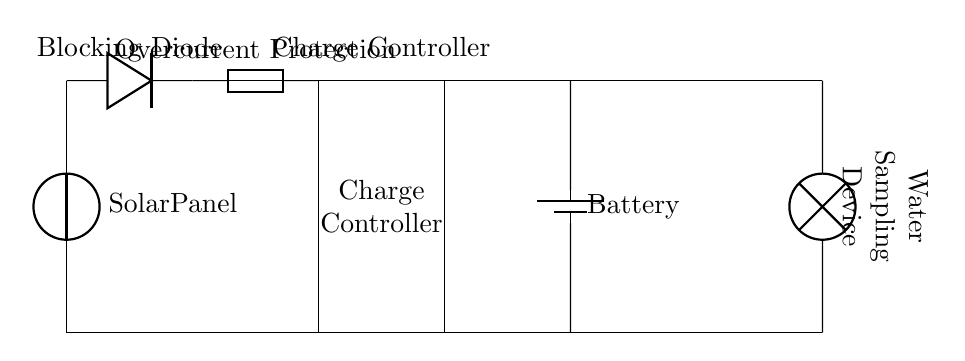What is the function of the blocking diode? The blocking diode prevents reverse current from flowing back into the solar panel when it is not generating power. It ensures that energy stored in the battery does not flow back to the solar panel at night or during low light conditions.
Answer: Preventing reverse current What component provides overcurrent protection? The component labeled "Overcurrent Protection" is a fuse. Its purpose is to break the circuit if the current exceeds a certain threshold, protecting other components from damage due to excessive current.
Answer: Fuse How many main components are there in the circuit? The circuit includes four main components: the solar panel, the diode, the charge controller, and the battery. This straightforward counting can be seen directly from the diagram.
Answer: Four What device is the load in this circuit? The load is labeled "Water Sampling Device" in the circuit. It is the component that consumes power from the battery to perform its function of sampling water.
Answer: Water Sampling Device What does the charge controller do? The charge controller regulates the voltage and current coming from the solar panel to the battery, ensuring that the battery is charged safely without overcharging or discharging too quickly.
Answer: Regulates charging What happens if the current exceeds the fuse rating? If the current exceeds the fuse rating, the fuse will blow, disconnecting the circuit and preventing further current flow. This protects downstream components from damage caused by excessive current.
Answer: Fuse blows 